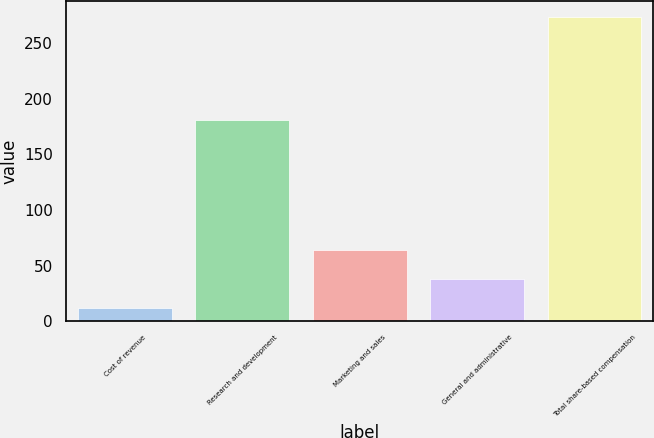Convert chart to OTSL. <chart><loc_0><loc_0><loc_500><loc_500><bar_chart><fcel>Cost of revenue<fcel>Research and development<fcel>Marketing and sales<fcel>General and administrative<fcel>Total share-based compensation<nl><fcel>12<fcel>181<fcel>64.4<fcel>38.2<fcel>274<nl></chart> 